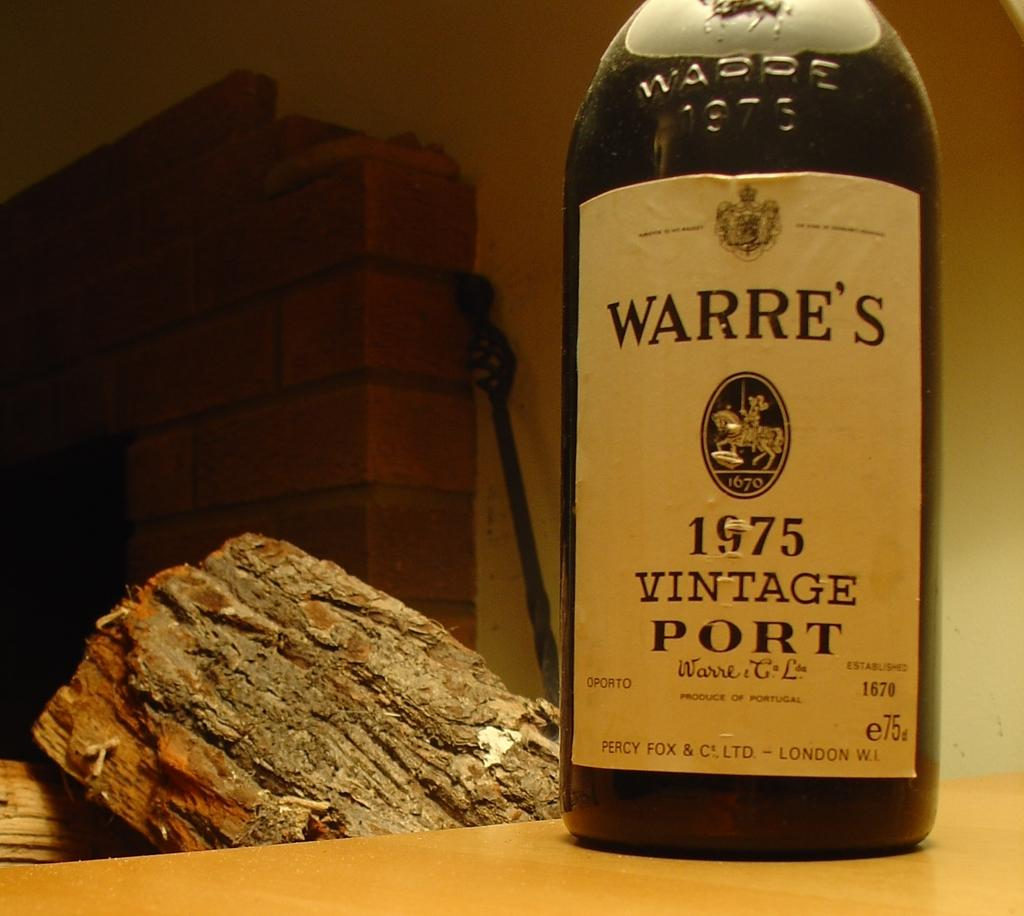<image>
Relay a brief, clear account of the picture shown. A low lit room with some wood in the background and An old vintage bottle of port from the year 1975 and is called Warre's 